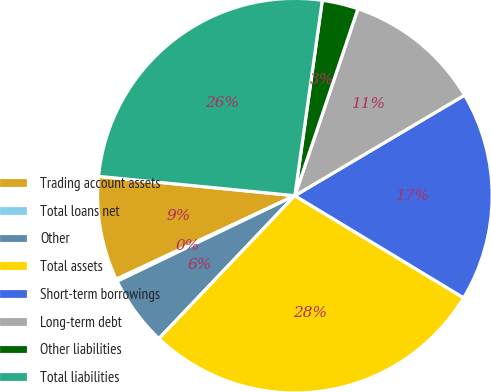Convert chart. <chart><loc_0><loc_0><loc_500><loc_500><pie_chart><fcel>Trading account assets<fcel>Total loans net<fcel>Other<fcel>Total assets<fcel>Short-term borrowings<fcel>Long-term debt<fcel>Other liabilities<fcel>Total liabilities<nl><fcel>8.53%<fcel>0.18%<fcel>5.75%<fcel>28.44%<fcel>17.17%<fcel>11.31%<fcel>2.96%<fcel>25.66%<nl></chart> 